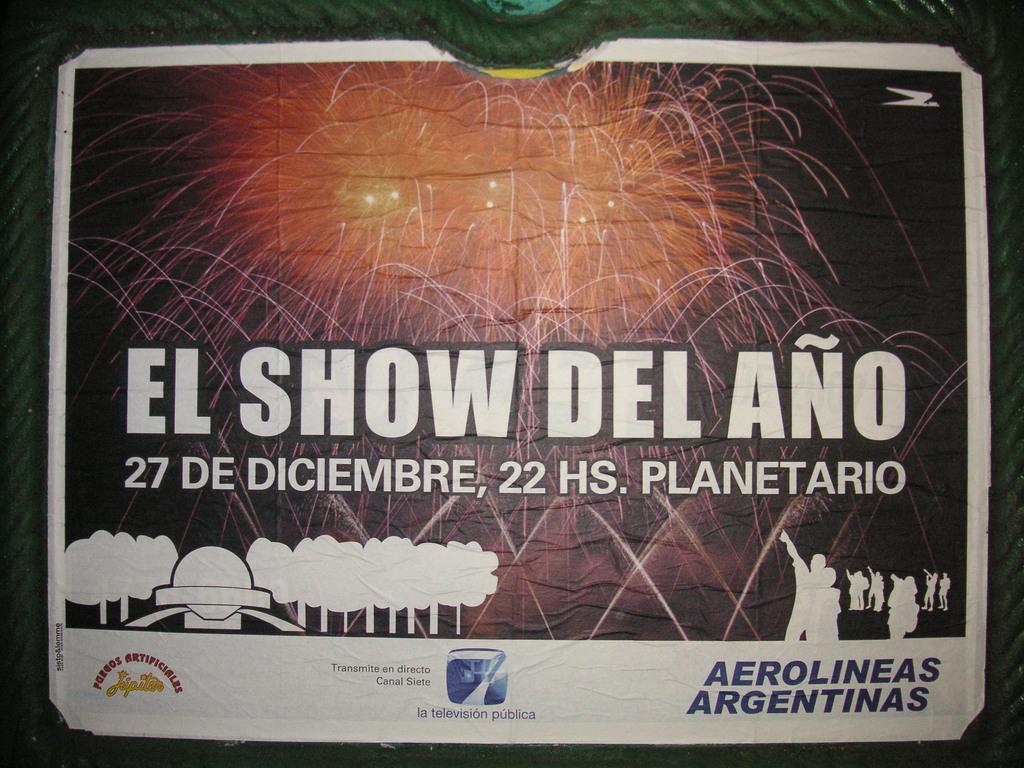What language is this?
Your response must be concise. Spanish. 